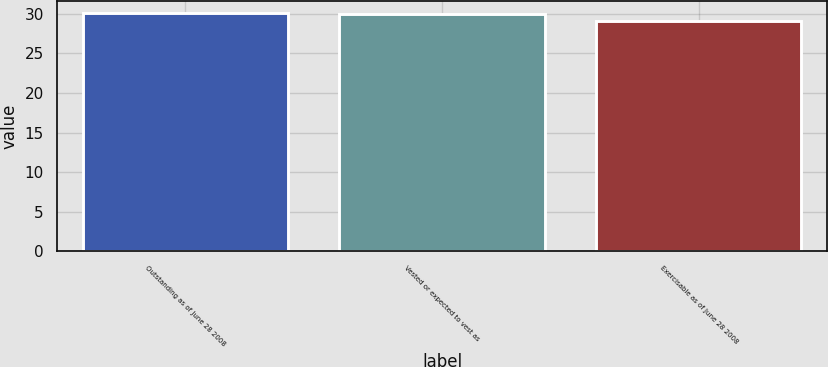Convert chart to OTSL. <chart><loc_0><loc_0><loc_500><loc_500><bar_chart><fcel>Outstanding as of June 28 2008<fcel>Vested or expected to vest as<fcel>Exercisable as of June 28 2008<nl><fcel>30.08<fcel>29.99<fcel>29.14<nl></chart> 